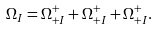<formula> <loc_0><loc_0><loc_500><loc_500>\Omega _ { I } = \Omega _ { + I } ^ { + } + \Omega _ { + I } ^ { + } + \Omega _ { + I } ^ { + } .</formula> 